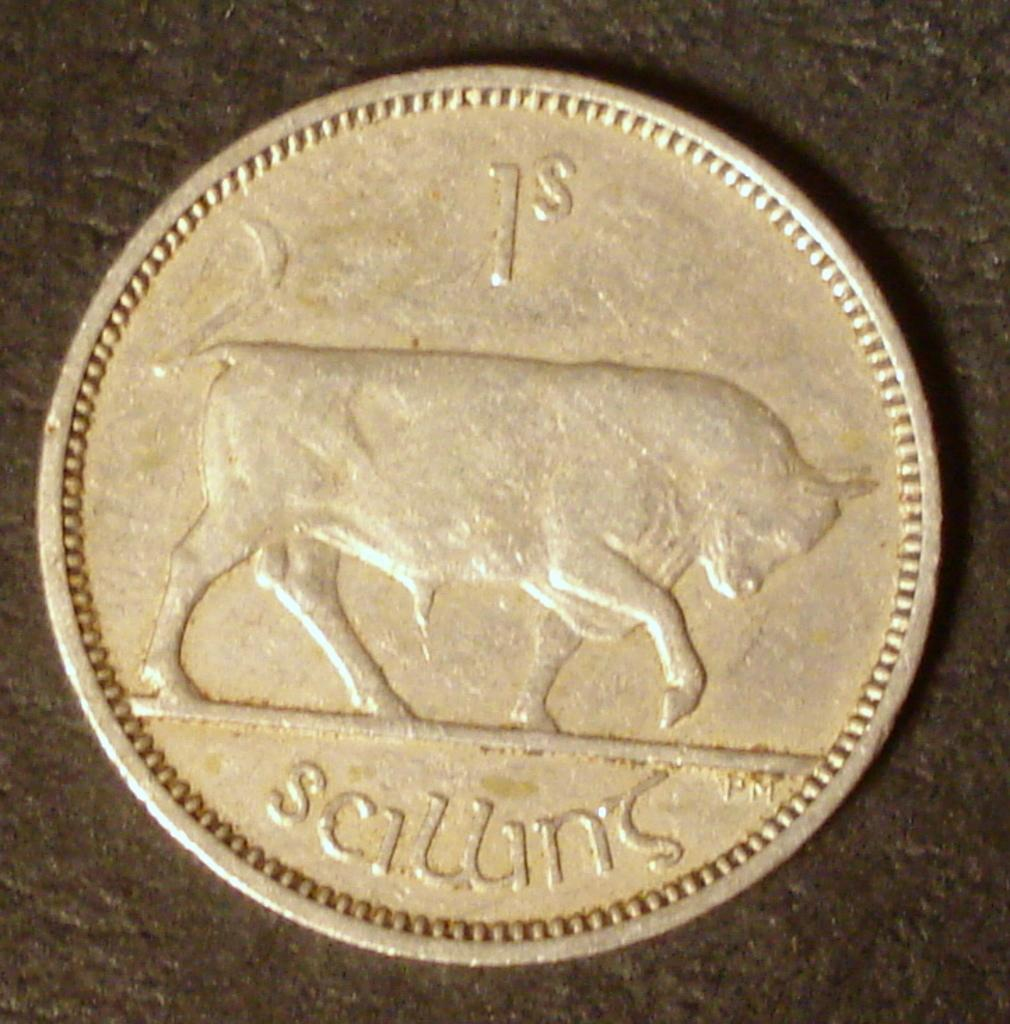<image>
Create a compact narrative representing the image presented. a close up of a coin for 1S shows a bull on it 